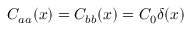Convert formula to latex. <formula><loc_0><loc_0><loc_500><loc_500>C _ { a a } ( x ) = C _ { b b } ( x ) = C _ { 0 } \delta ( x )</formula> 